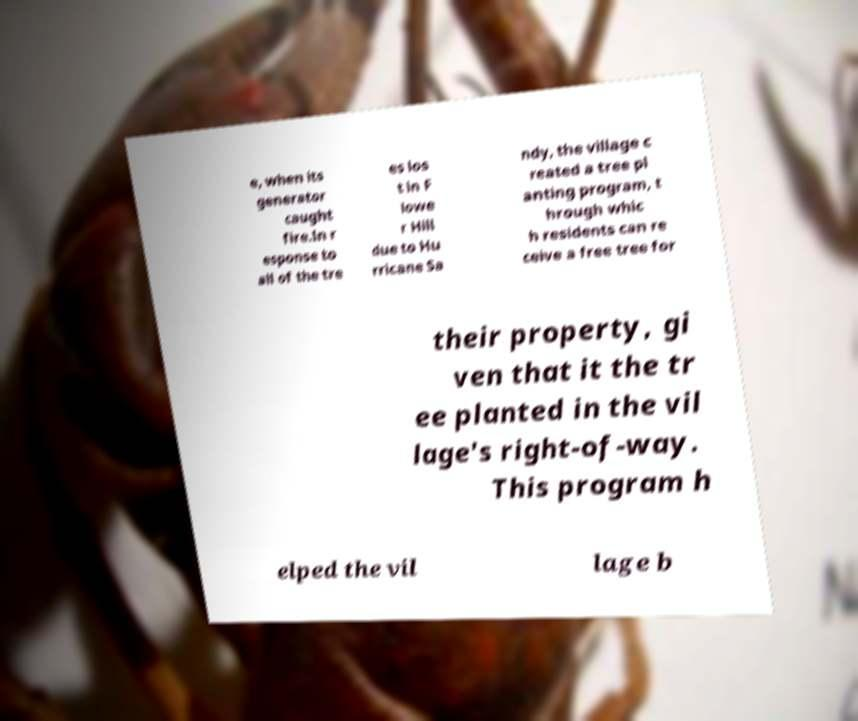For documentation purposes, I need the text within this image transcribed. Could you provide that? e, when its generator caught fire.In r esponse to all of the tre es los t in F lowe r Hill due to Hu rricane Sa ndy, the village c reated a tree pl anting program, t hrough whic h residents can re ceive a free tree for their property, gi ven that it the tr ee planted in the vil lage's right-of-way. This program h elped the vil lage b 